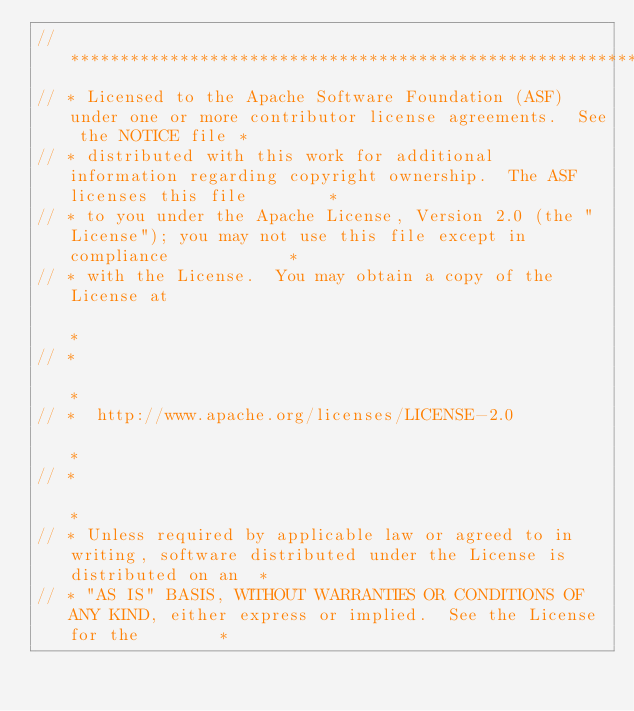Convert code to text. <code><loc_0><loc_0><loc_500><loc_500><_Java_>// ***************************************************************************************************************************
// * Licensed to the Apache Software Foundation (ASF) under one or more contributor license agreements.  See the NOTICE file *
// * distributed with this work for additional information regarding copyright ownership.  The ASF licenses this file        *
// * to you under the Apache License, Version 2.0 (the "License"); you may not use this file except in compliance            *
// * with the License.  You may obtain a copy of the License at                                                              *
// *                                                                                                                         *
// *  http://www.apache.org/licenses/LICENSE-2.0                                                                             *
// *                                                                                                                         *
// * Unless required by applicable law or agreed to in writing, software distributed under the License is distributed on an  *
// * "AS IS" BASIS, WITHOUT WARRANTIES OR CONDITIONS OF ANY KIND, either express or implied.  See the License for the        *</code> 